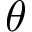Convert formula to latex. <formula><loc_0><loc_0><loc_500><loc_500>\theta</formula> 